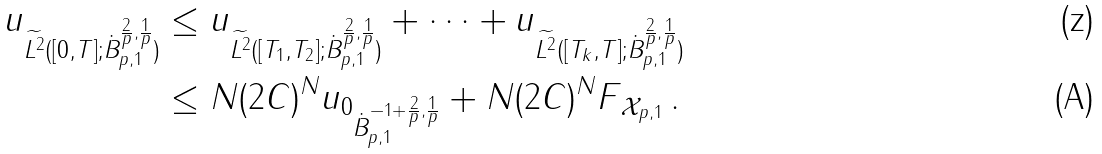<formula> <loc_0><loc_0><loc_500><loc_500>\| u \| _ { \widetilde { L ^ { 2 } } ( [ 0 , T ] ; \dot { B } ^ { \frac { 2 } { p } , \frac { 1 } { p } } _ { p , 1 } ) } & \leq \| u \| _ { \widetilde { L ^ { 2 } } ( [ T _ { 1 } , T _ { 2 } ] ; \dot { B } ^ { \frac { 2 } { p } , \frac { 1 } { p } } _ { p , 1 } ) } + \dots + \| u \| _ { \widetilde { L ^ { 2 } } ( [ T _ { k } , T ] ; \dot { B } ^ { \frac { 2 } { p } , \frac { 1 } { p } } _ { p , 1 } ) } \\ & \leq N ( 2 C ) ^ { N } \| u _ { 0 } \| _ { \dot { B } ^ { - 1 + \frac { 2 } { p } , \frac { 1 } { p } } _ { p , 1 } } + N ( 2 C ) ^ { N } \| F \| _ { { \mathcal { X } } _ { p , 1 } } \, .</formula> 